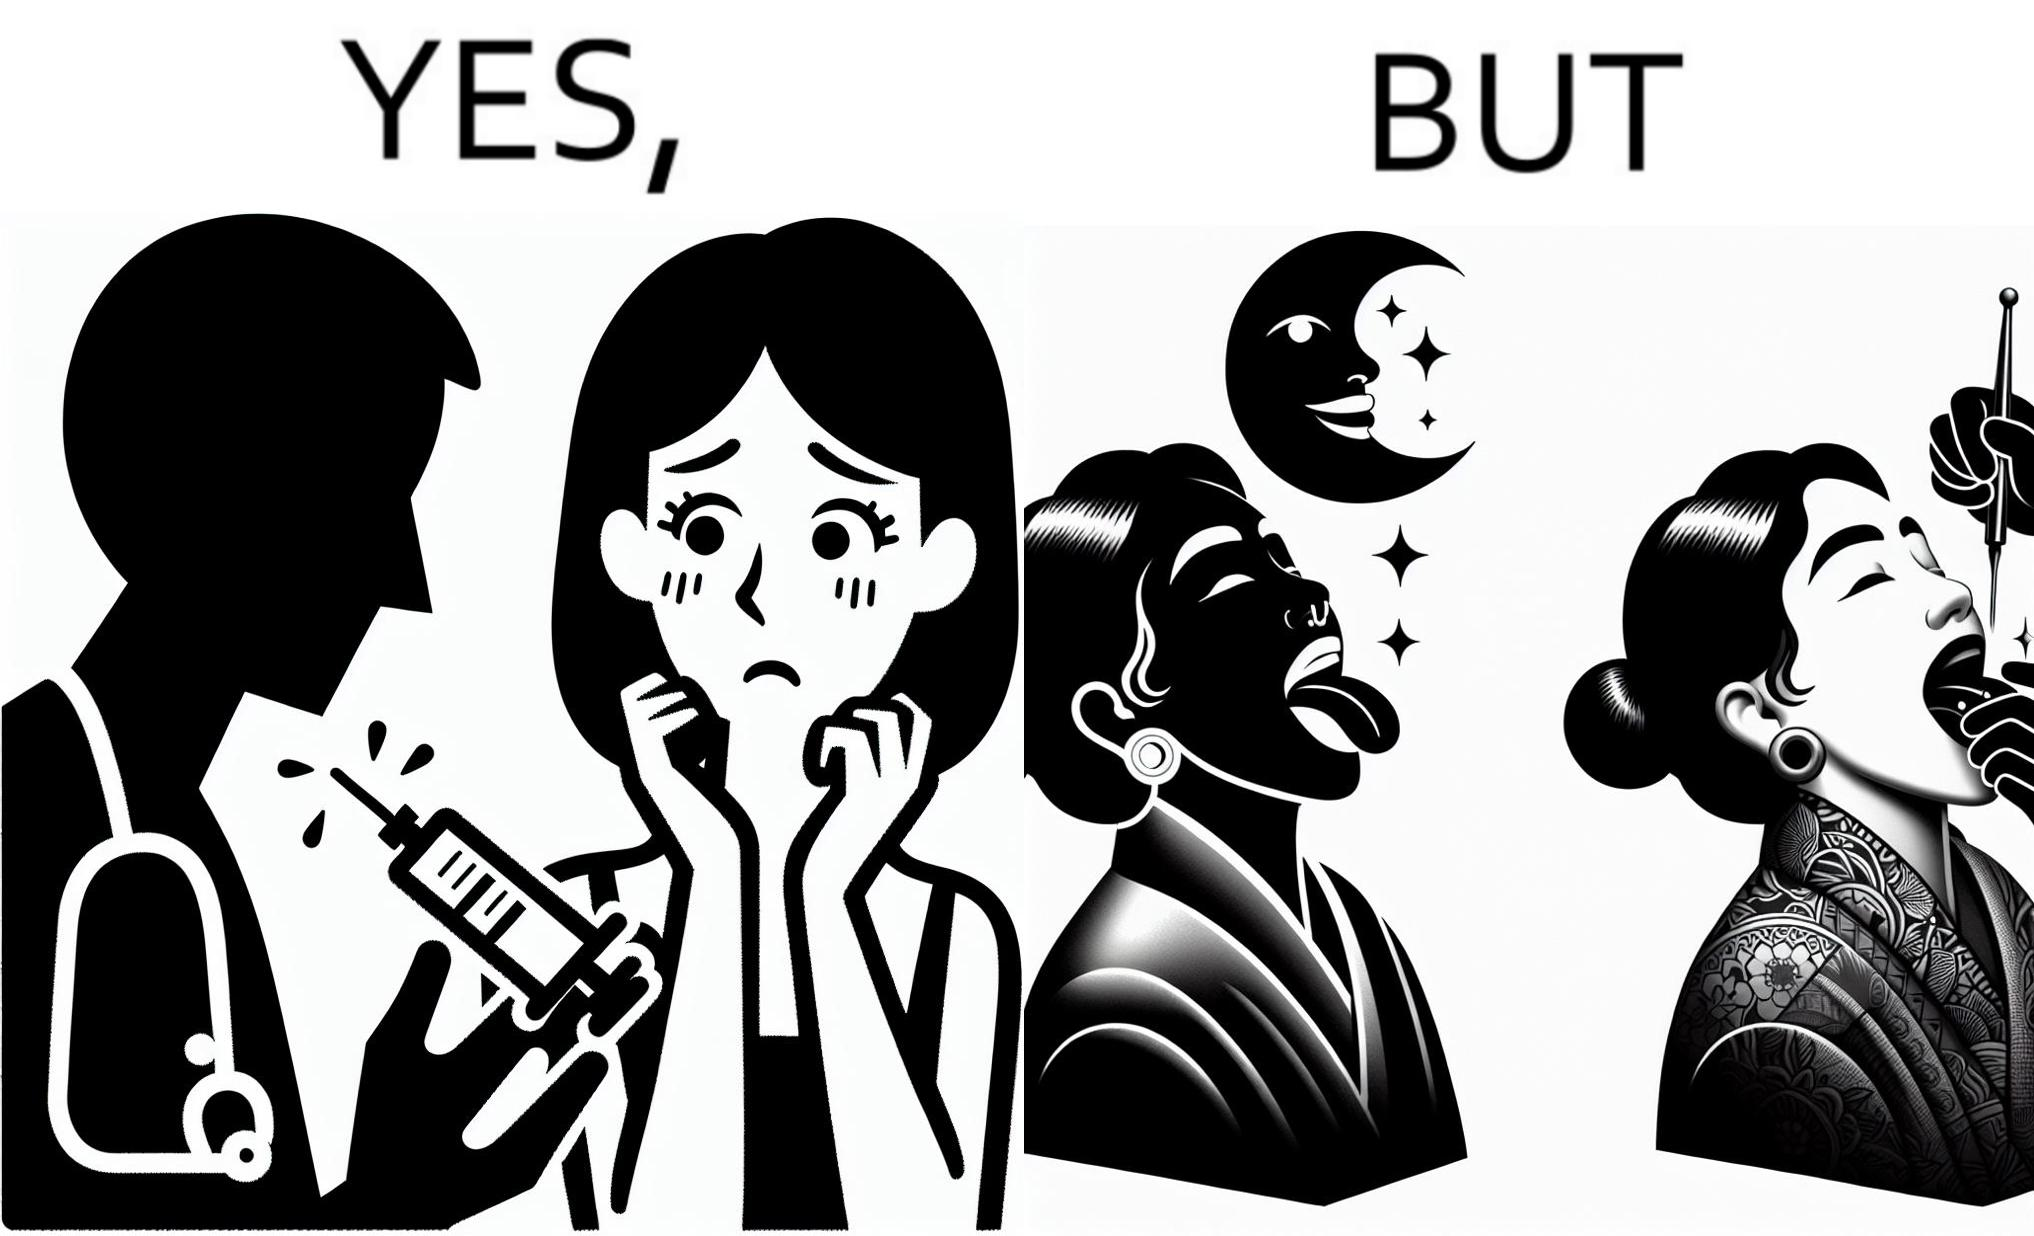Describe what you see in this image. The image is funny becuase while the woman is scared of getting an injection which is for her benefit, she is not afraid of getting a piercing or a tattoo which are not going to help her in any way. 